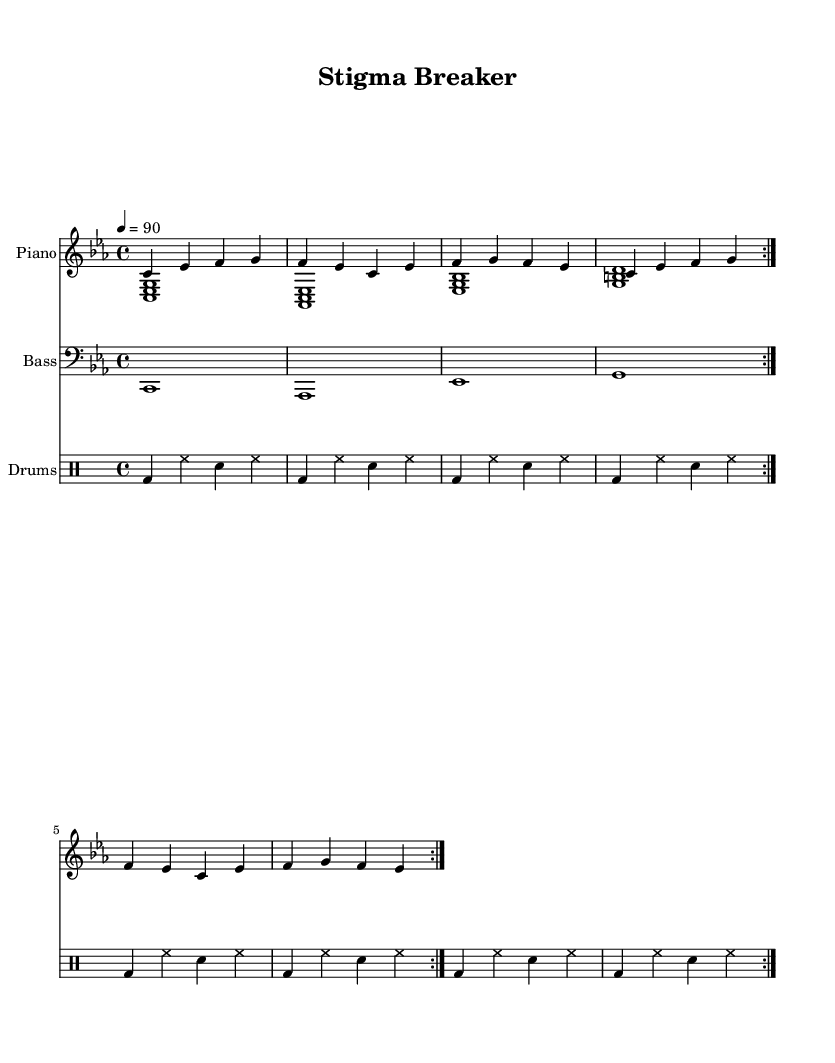What is the key signature of this music? The key signature indicated in the sheet music is C minor, which has three flats (B♭, E♭, and A♭).
Answer: C minor What is the time signature of this music? The time signature specified in the sheet music is 4/4, meaning there are four beats per measure, and the quarter note gets one beat.
Answer: 4/4 What is the tempo marking for this piece? The tempo marking displays a quarter note equals 90 beats per minute, indicating the speed at which the music should be played.
Answer: 90 How many measures are in the repeat section? Observing the repeated sections of both the piano and drums, we can count a total of four measures for each repeat, and since it repeats twice, there are entirely eight measures before any conclusion.
Answer: 8 Which instruments are included in this sheet music? The instruments specified in the score are Piano, Bass, and Drums, with distinct parts for both piano hands as well as separate sections for bass and drums.
Answer: Piano, Bass, Drums Is there a specific focus on rhythm in this rap piece? The drum patterns show a heavy emphasis on the bass drum and snare, which is typical for rap, as it establishes a strong rhythm, creating a solid foundation for the lyrical flow.
Answer: Yes 